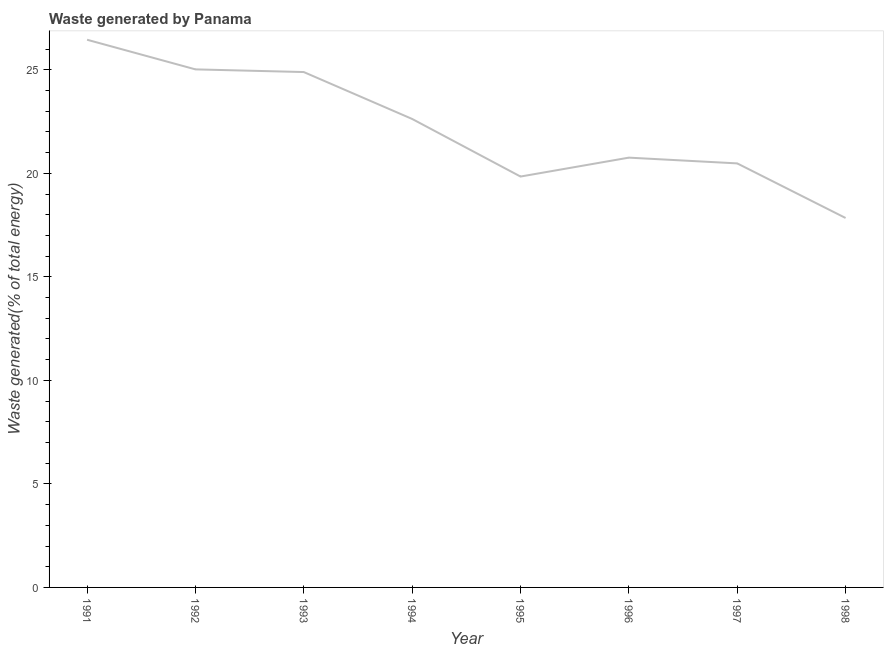What is the amount of waste generated in 1991?
Keep it short and to the point. 26.45. Across all years, what is the maximum amount of waste generated?
Your response must be concise. 26.45. Across all years, what is the minimum amount of waste generated?
Offer a terse response. 17.84. In which year was the amount of waste generated maximum?
Your response must be concise. 1991. What is the sum of the amount of waste generated?
Provide a succinct answer. 177.91. What is the difference between the amount of waste generated in 1993 and 1994?
Provide a short and direct response. 2.26. What is the average amount of waste generated per year?
Your answer should be compact. 22.24. What is the median amount of waste generated?
Keep it short and to the point. 21.69. Do a majority of the years between 1995 and 1991 (inclusive) have amount of waste generated greater than 6 %?
Ensure brevity in your answer.  Yes. What is the ratio of the amount of waste generated in 1991 to that in 1998?
Make the answer very short. 1.48. Is the amount of waste generated in 1991 less than that in 1995?
Your answer should be very brief. No. What is the difference between the highest and the second highest amount of waste generated?
Offer a terse response. 1.43. What is the difference between the highest and the lowest amount of waste generated?
Provide a succinct answer. 8.61. How many lines are there?
Make the answer very short. 1. What is the difference between two consecutive major ticks on the Y-axis?
Your response must be concise. 5. Are the values on the major ticks of Y-axis written in scientific E-notation?
Provide a short and direct response. No. Does the graph contain grids?
Your answer should be very brief. No. What is the title of the graph?
Provide a succinct answer. Waste generated by Panama. What is the label or title of the Y-axis?
Provide a succinct answer. Waste generated(% of total energy). What is the Waste generated(% of total energy) of 1991?
Provide a succinct answer. 26.45. What is the Waste generated(% of total energy) in 1992?
Make the answer very short. 25.02. What is the Waste generated(% of total energy) in 1993?
Make the answer very short. 24.89. What is the Waste generated(% of total energy) of 1994?
Provide a succinct answer. 22.63. What is the Waste generated(% of total energy) of 1995?
Provide a short and direct response. 19.84. What is the Waste generated(% of total energy) of 1996?
Your answer should be very brief. 20.76. What is the Waste generated(% of total energy) in 1997?
Ensure brevity in your answer.  20.48. What is the Waste generated(% of total energy) of 1998?
Make the answer very short. 17.84. What is the difference between the Waste generated(% of total energy) in 1991 and 1992?
Ensure brevity in your answer.  1.43. What is the difference between the Waste generated(% of total energy) in 1991 and 1993?
Your answer should be very brief. 1.56. What is the difference between the Waste generated(% of total energy) in 1991 and 1994?
Offer a very short reply. 3.83. What is the difference between the Waste generated(% of total energy) in 1991 and 1995?
Offer a terse response. 6.61. What is the difference between the Waste generated(% of total energy) in 1991 and 1996?
Make the answer very short. 5.69. What is the difference between the Waste generated(% of total energy) in 1991 and 1997?
Offer a terse response. 5.97. What is the difference between the Waste generated(% of total energy) in 1991 and 1998?
Make the answer very short. 8.61. What is the difference between the Waste generated(% of total energy) in 1992 and 1993?
Make the answer very short. 0.13. What is the difference between the Waste generated(% of total energy) in 1992 and 1994?
Offer a very short reply. 2.39. What is the difference between the Waste generated(% of total energy) in 1992 and 1995?
Keep it short and to the point. 5.18. What is the difference between the Waste generated(% of total energy) in 1992 and 1996?
Offer a terse response. 4.26. What is the difference between the Waste generated(% of total energy) in 1992 and 1997?
Your answer should be compact. 4.54. What is the difference between the Waste generated(% of total energy) in 1992 and 1998?
Offer a very short reply. 7.18. What is the difference between the Waste generated(% of total energy) in 1993 and 1994?
Offer a terse response. 2.26. What is the difference between the Waste generated(% of total energy) in 1993 and 1995?
Your response must be concise. 5.05. What is the difference between the Waste generated(% of total energy) in 1993 and 1996?
Provide a short and direct response. 4.13. What is the difference between the Waste generated(% of total energy) in 1993 and 1997?
Offer a terse response. 4.41. What is the difference between the Waste generated(% of total energy) in 1993 and 1998?
Ensure brevity in your answer.  7.05. What is the difference between the Waste generated(% of total energy) in 1994 and 1995?
Provide a short and direct response. 2.78. What is the difference between the Waste generated(% of total energy) in 1994 and 1996?
Your response must be concise. 1.87. What is the difference between the Waste generated(% of total energy) in 1994 and 1997?
Your response must be concise. 2.15. What is the difference between the Waste generated(% of total energy) in 1994 and 1998?
Your response must be concise. 4.78. What is the difference between the Waste generated(% of total energy) in 1995 and 1996?
Your answer should be compact. -0.91. What is the difference between the Waste generated(% of total energy) in 1995 and 1997?
Ensure brevity in your answer.  -0.63. What is the difference between the Waste generated(% of total energy) in 1995 and 1998?
Keep it short and to the point. 2. What is the difference between the Waste generated(% of total energy) in 1996 and 1997?
Provide a short and direct response. 0.28. What is the difference between the Waste generated(% of total energy) in 1996 and 1998?
Your response must be concise. 2.91. What is the difference between the Waste generated(% of total energy) in 1997 and 1998?
Give a very brief answer. 2.64. What is the ratio of the Waste generated(% of total energy) in 1991 to that in 1992?
Your answer should be very brief. 1.06. What is the ratio of the Waste generated(% of total energy) in 1991 to that in 1993?
Make the answer very short. 1.06. What is the ratio of the Waste generated(% of total energy) in 1991 to that in 1994?
Offer a very short reply. 1.17. What is the ratio of the Waste generated(% of total energy) in 1991 to that in 1995?
Offer a terse response. 1.33. What is the ratio of the Waste generated(% of total energy) in 1991 to that in 1996?
Your answer should be compact. 1.27. What is the ratio of the Waste generated(% of total energy) in 1991 to that in 1997?
Your answer should be very brief. 1.29. What is the ratio of the Waste generated(% of total energy) in 1991 to that in 1998?
Your response must be concise. 1.48. What is the ratio of the Waste generated(% of total energy) in 1992 to that in 1994?
Make the answer very short. 1.11. What is the ratio of the Waste generated(% of total energy) in 1992 to that in 1995?
Provide a short and direct response. 1.26. What is the ratio of the Waste generated(% of total energy) in 1992 to that in 1996?
Make the answer very short. 1.21. What is the ratio of the Waste generated(% of total energy) in 1992 to that in 1997?
Keep it short and to the point. 1.22. What is the ratio of the Waste generated(% of total energy) in 1992 to that in 1998?
Keep it short and to the point. 1.4. What is the ratio of the Waste generated(% of total energy) in 1993 to that in 1994?
Your answer should be very brief. 1.1. What is the ratio of the Waste generated(% of total energy) in 1993 to that in 1995?
Ensure brevity in your answer.  1.25. What is the ratio of the Waste generated(% of total energy) in 1993 to that in 1996?
Provide a succinct answer. 1.2. What is the ratio of the Waste generated(% of total energy) in 1993 to that in 1997?
Offer a very short reply. 1.22. What is the ratio of the Waste generated(% of total energy) in 1993 to that in 1998?
Your answer should be compact. 1.4. What is the ratio of the Waste generated(% of total energy) in 1994 to that in 1995?
Offer a terse response. 1.14. What is the ratio of the Waste generated(% of total energy) in 1994 to that in 1996?
Your answer should be compact. 1.09. What is the ratio of the Waste generated(% of total energy) in 1994 to that in 1997?
Provide a short and direct response. 1.1. What is the ratio of the Waste generated(% of total energy) in 1994 to that in 1998?
Ensure brevity in your answer.  1.27. What is the ratio of the Waste generated(% of total energy) in 1995 to that in 1996?
Your answer should be very brief. 0.96. What is the ratio of the Waste generated(% of total energy) in 1995 to that in 1997?
Give a very brief answer. 0.97. What is the ratio of the Waste generated(% of total energy) in 1995 to that in 1998?
Give a very brief answer. 1.11. What is the ratio of the Waste generated(% of total energy) in 1996 to that in 1997?
Provide a succinct answer. 1.01. What is the ratio of the Waste generated(% of total energy) in 1996 to that in 1998?
Provide a short and direct response. 1.16. What is the ratio of the Waste generated(% of total energy) in 1997 to that in 1998?
Ensure brevity in your answer.  1.15. 